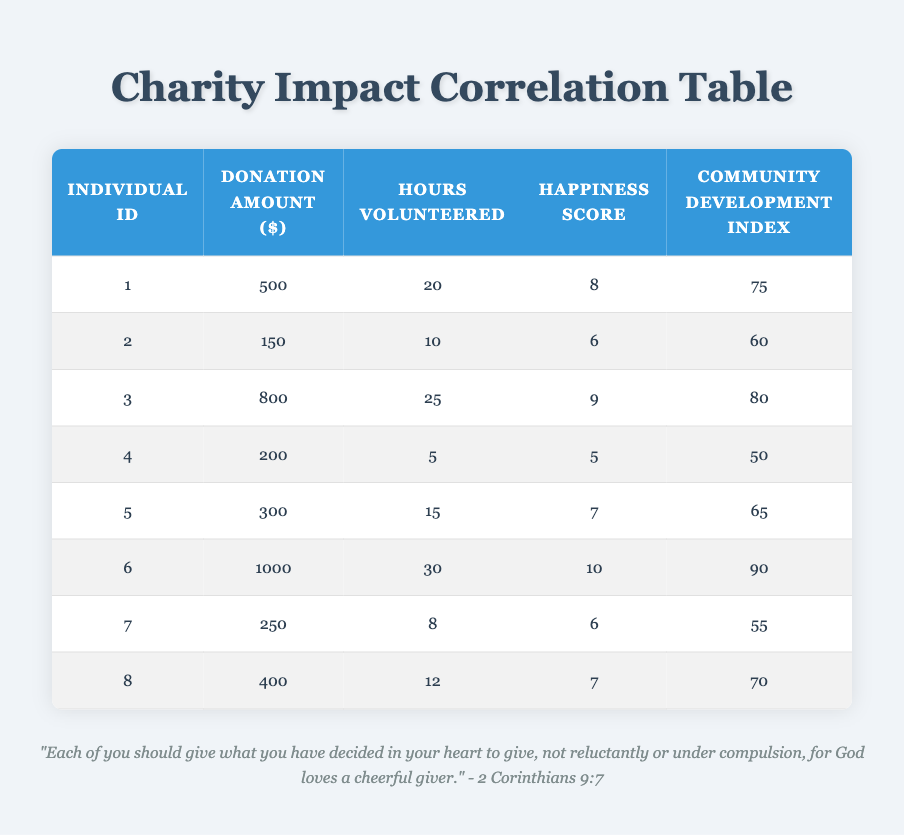What is the highest donation amount recorded in the table? The highest donation amount can be found by scanning through the 'Donation Amount' column. The value listed for Individual_ID 6 is the largest at $1000.
Answer: 1000 What is the community development index for the individual who donated $400? To find this, look for the row where the 'Donation Amount' is $400. The 'Community Development Index' corresponding to this entry (Individual_ID 8) is 70.
Answer: 70 Is the happiness score of Individual_ID 3 greater than 8? Individual_ID 3 has a happiness score of 9, which is indeed greater than 8, confirming the statement.
Answer: Yes What is the average happiness score of all individuals listed in the table? To calculate the average, add the happiness scores (8 + 6 + 9 + 5 + 7 + 10 + 6 + 7) = 58. Then divide by the number of individuals (8), which results in an average of 58/8 = 7.25.
Answer: 7.25 How many hours did Individual_ID 1 volunteer, and how does it compare to the hours volunteered by Individual_ID 4? Individual_ID 1 volunteered for 20 hours, while Individual_ID 4 volunteered for 5 hours. Comparing both, 20 hours is significantly greater than 5 hours.
Answer: 20 hours, greater than 5 What is the total amount donated by individuals who scored a happiness score of 10? Only Individual_ID 6 scored a happiness score of 10, and their donation amount is $1000. Therefore, the total amount for individuals with a score of 10 is $1000.
Answer: 1000 Are there any individuals who volunteered less than 10 hours? Individual_ID 4 volunteered only 5 hours and Individual_ID 7 volunteered 8 hours, both of which are less than 10 hours. Thus, the answer is yes, there are individuals who fit this criterion.
Answer: Yes What is the difference in the community development index between the individual with the highest donation and the one with the lowest? The highest donation is $1000 (Individual_ID 6) with a community development index of 90, and the lowest recorded donation is $150 (Individual_ID 2) with an index of 60. The difference is 90 - 60 = 30.
Answer: 30 What is the total donation amount from individuals who volunteered more than 15 hours? Individuals who volunteered more than 15 hours are Individual_ID 1 (500), Individual_ID 3 (800), and Individual_ID 6 (1000). Summing their donations gives us 500 + 800 + 1000 = 2300.
Answer: 2300 